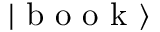<formula> <loc_0><loc_0><loc_500><loc_500>\left | b o o k \right \rangle</formula> 